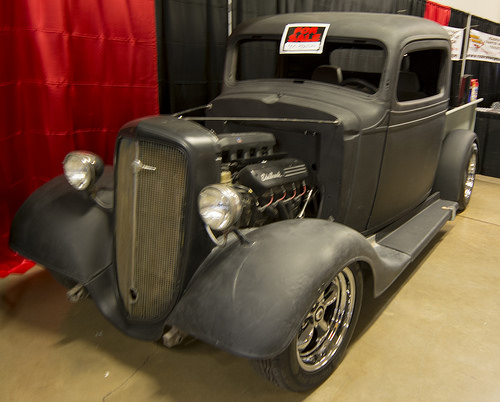<image>
Is the sign behind the truck? No. The sign is not behind the truck. From this viewpoint, the sign appears to be positioned elsewhere in the scene. Is the sign next to the car? No. The sign is not positioned next to the car. They are located in different areas of the scene. 